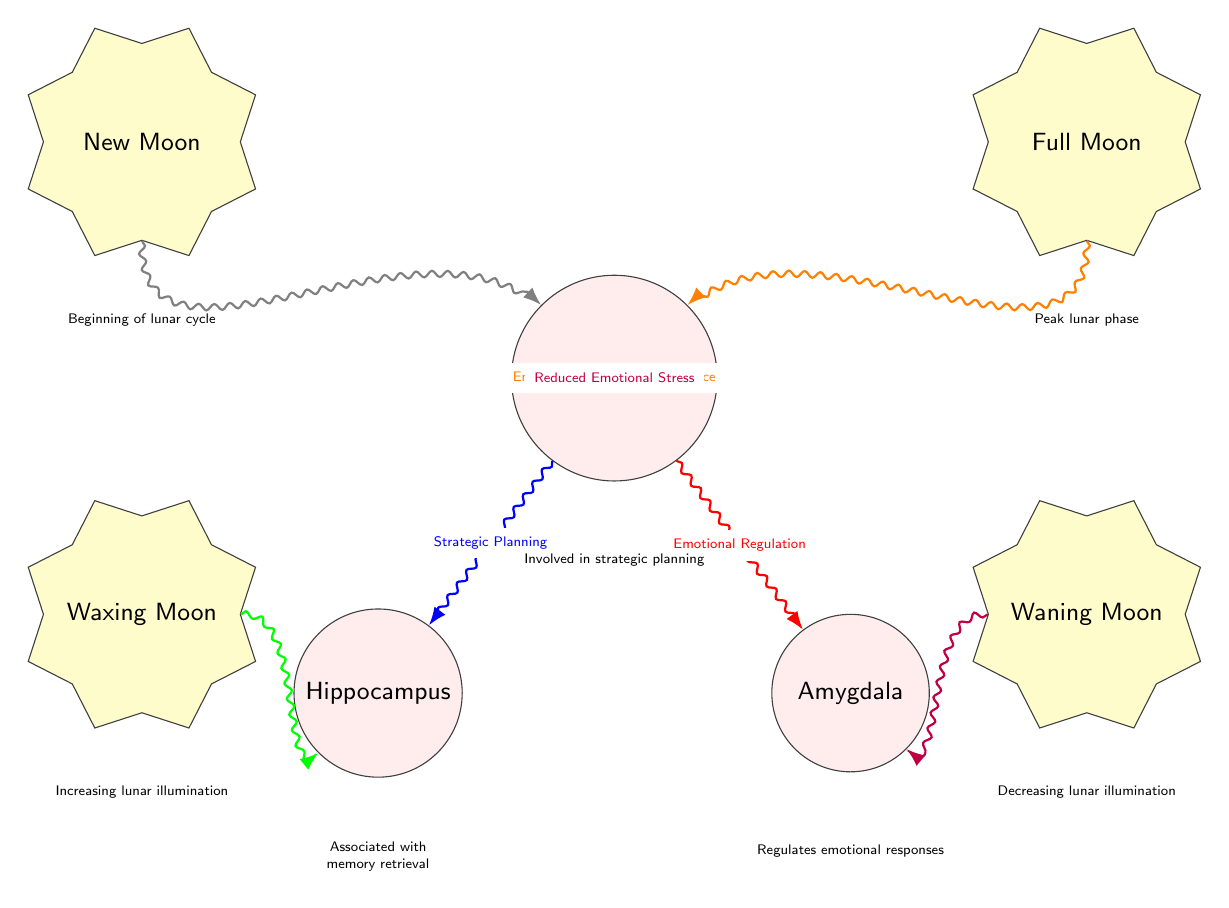What are the three brain regions depicted in the diagram? The diagram shows three brain regions: Prefrontal Cortex, Hippocampus, and Amygdala. These nodes are labeled explicitly in the diagram.
Answer: Prefrontal Cortex, Hippocampus, Amygdala Which moon phase is associated with "Enhanced Cognitive Performance"? The diagram indicates that the Full Moon phase is connected to Enhanced Cognitive Performance, as shown by the arrow pointing toward the Prefrontal Cortex from the Full Moon.
Answer: Full Moon How many lunar phases are represented in the diagram? There are four lunar phases represented: Full Moon, New Moon, Waxing Moon, and Waning Moon. The diagram clearly displays these four nodes.
Answer: 4 What connection is made from the Prefrontal Cortex to the Hippocampus? The connection labeled "Strategic Planning" exists between the Prefrontal Cortex and Hippocampus, indicating a relationship that reflects cognitive function in this context.
Answer: Strategic Planning Which lunar phase is related to "Memory Enhancement"? The Waxing Moon phase is linked to Memory Enhancement, as indicated by the directed connection to the Hippocampus in the diagram.
Answer: Waxing Moon What is the function of the Amygdala as noted in the diagram? The diagram states that the Amygdala regulates emotional responses, which is a function associated with this brain region.
Answer: Regulates emotional responses During which lunar phase does the diagram indicate "Baseline Cognition"? The New Moon phase is correlated with Baseline Cognition, as represented by the arrow pointing toward the Prefrontal Cortex and labeled accordingly.
Answer: New Moon What does the arrow from the Waning Moon point to, and what does it signify? The arrow from the Waning Moon points to the Amygdala and signifies "Reduced Emotional Stress," suggesting a connection during this lunar phase.
Answer: Reduced Emotional Stress What color signifies the connection for "Emotional Regulation"? The connection for Emotional Regulation is represented in red, indicating its specific role in the diagram with the Prefrontal Cortex and Amygdala.
Answer: Red 